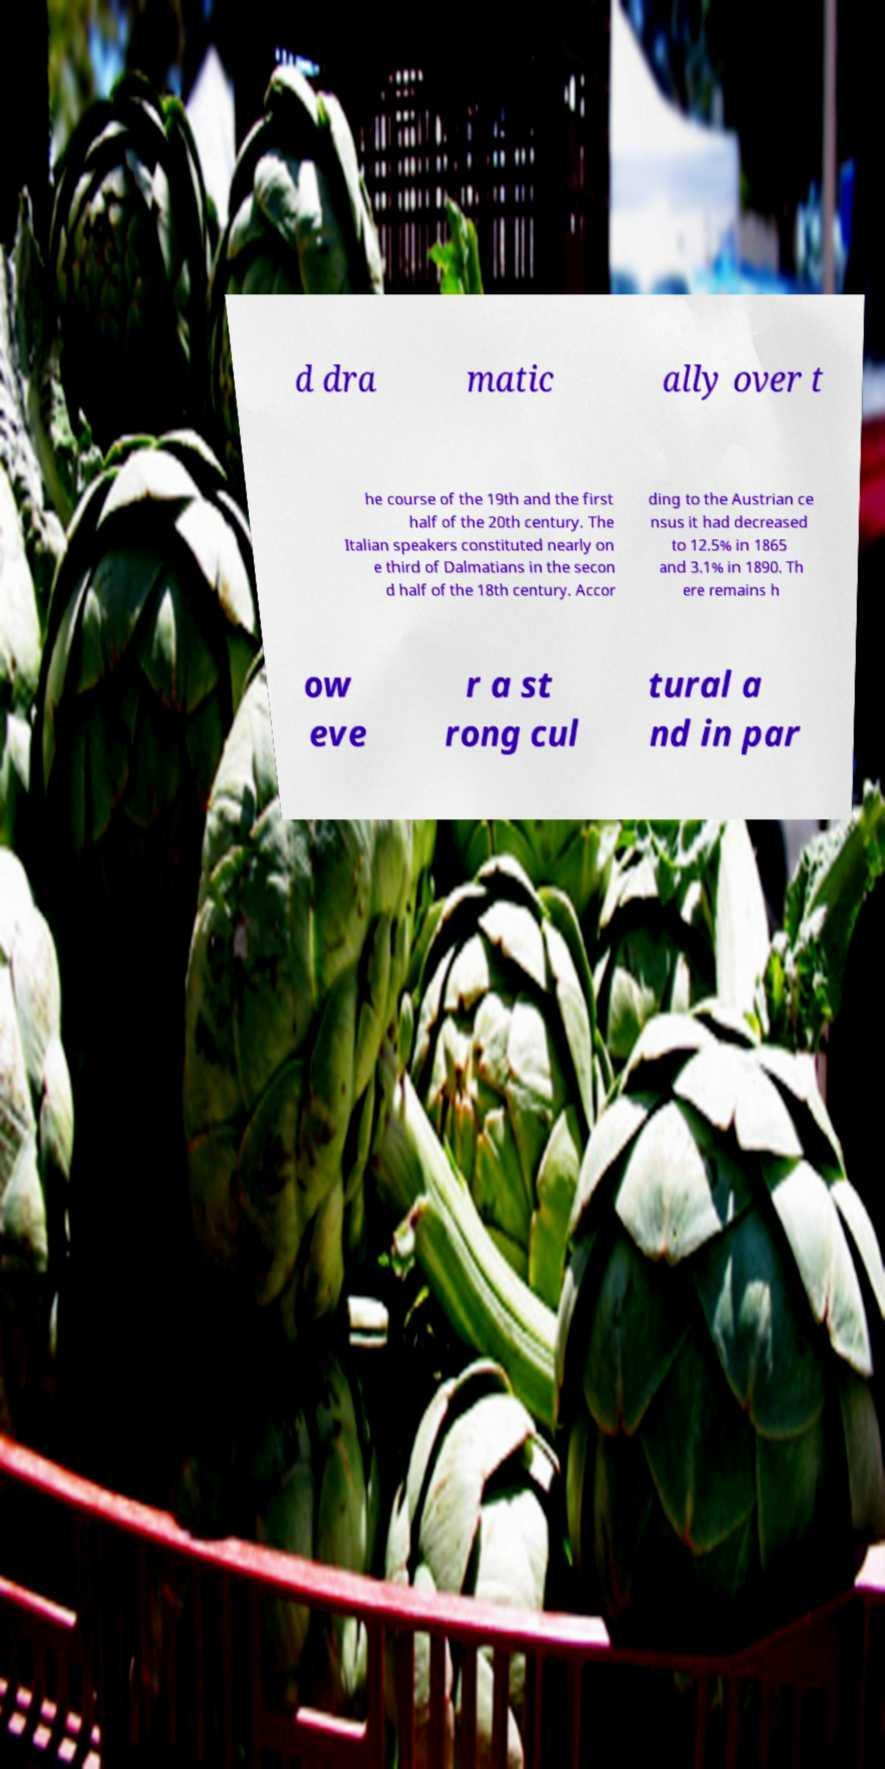Please identify and transcribe the text found in this image. d dra matic ally over t he course of the 19th and the first half of the 20th century. The Italian speakers constituted nearly on e third of Dalmatians in the secon d half of the 18th century. Accor ding to the Austrian ce nsus it had decreased to 12.5% in 1865 and 3.1% in 1890. Th ere remains h ow eve r a st rong cul tural a nd in par 